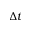Convert formula to latex. <formula><loc_0><loc_0><loc_500><loc_500>\Delta t</formula> 